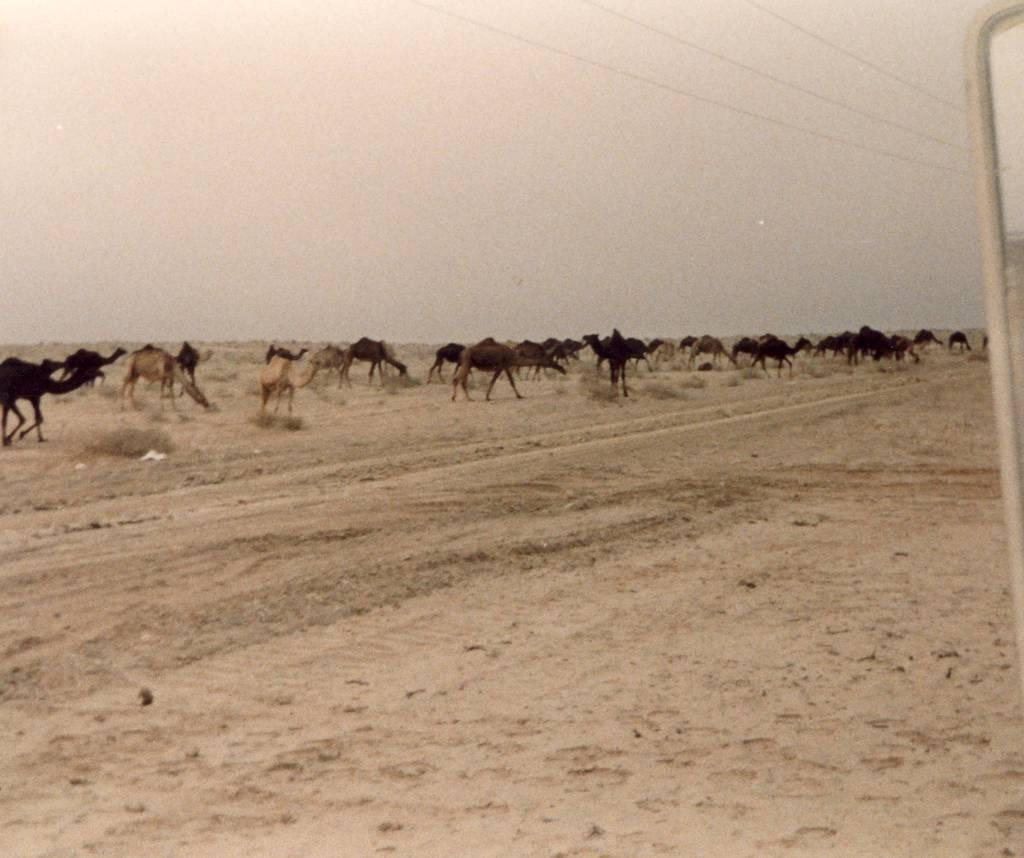What animals are present in the image? There is a group of camels in the image. What type of terrain are the camels on? The camels are on sand. Are there any plants visible in the image? Yes, there are plants in the image. What structures can be seen in the image? There is a pole and wires in the image. What is visible in the background of the image? The sky is visible in the background of the image. What type of magic is being performed by the camels in the image? There is no magic being performed by the camels in the image; they are simply standing on sand. Is there a park visible in the image? There is no park present in the image; it features a group of camels on sand with plants, a pole, and wires. 